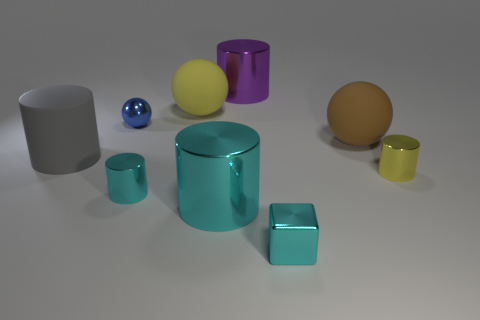The small cylinder that is in front of the tiny cylinder that is right of the cylinder that is behind the big brown ball is made of what material?
Make the answer very short. Metal. Is the number of brown objects that are left of the large cyan shiny thing greater than the number of yellow balls on the right side of the brown object?
Give a very brief answer. No. Does the metal sphere have the same size as the gray rubber thing?
Make the answer very short. No. There is another metal object that is the same shape as the brown object; what color is it?
Give a very brief answer. Blue. What number of large rubber objects have the same color as the tiny sphere?
Give a very brief answer. 0. Are there more gray objects that are to the left of the purple metal cylinder than blue cylinders?
Keep it short and to the point. Yes. The large metal thing in front of the large shiny object behind the brown rubber sphere is what color?
Offer a very short reply. Cyan. How many things are tiny cylinders on the right side of the cube or big cylinders that are in front of the gray cylinder?
Keep it short and to the point. 2. What is the color of the tiny metal sphere?
Make the answer very short. Blue. How many large yellow objects are the same material as the big gray cylinder?
Keep it short and to the point. 1. 